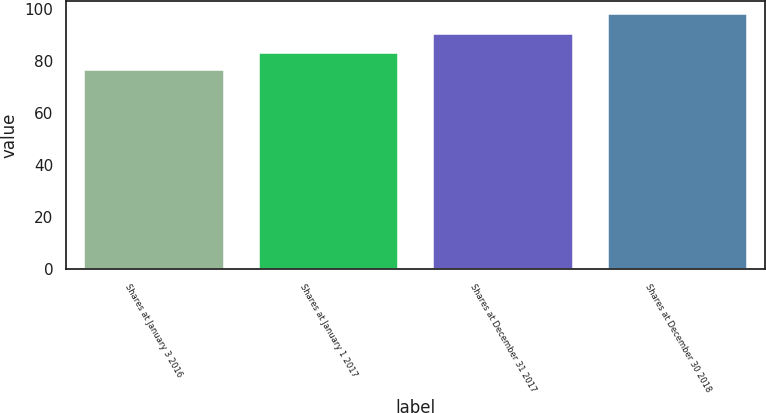<chart> <loc_0><loc_0><loc_500><loc_500><bar_chart><fcel>Shares at January 3 2016<fcel>Shares at January 1 2017<fcel>Shares at December 31 2017<fcel>Shares at December 30 2018<nl><fcel>76.41<fcel>83.16<fcel>90.48<fcel>98.29<nl></chart> 